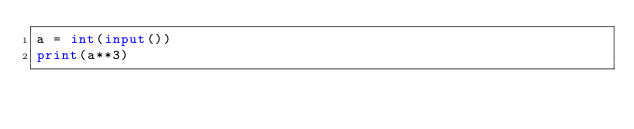<code> <loc_0><loc_0><loc_500><loc_500><_Python_>a = int(input())
print(a**3)
</code> 